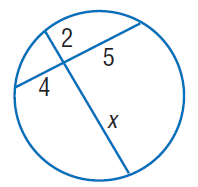Answer the mathemtical geometry problem and directly provide the correct option letter.
Question: Find x. Round to the nearest tenth if necessary. Assume that segments that appear to be tangent are tangent.
Choices: A: 2 B: 4 C: 5 D: 10 D 